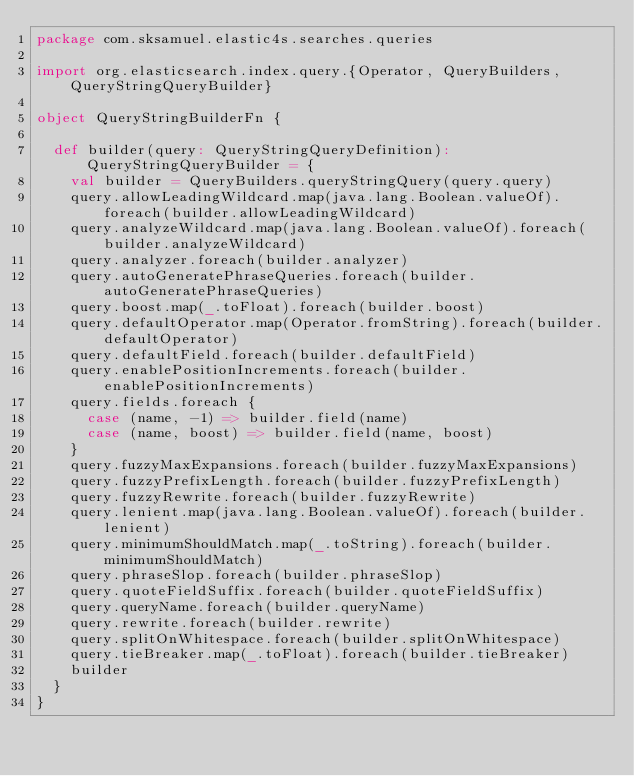Convert code to text. <code><loc_0><loc_0><loc_500><loc_500><_Scala_>package com.sksamuel.elastic4s.searches.queries

import org.elasticsearch.index.query.{Operator, QueryBuilders, QueryStringQueryBuilder}

object QueryStringBuilderFn {

  def builder(query: QueryStringQueryDefinition): QueryStringQueryBuilder = {
    val builder = QueryBuilders.queryStringQuery(query.query)
    query.allowLeadingWildcard.map(java.lang.Boolean.valueOf).foreach(builder.allowLeadingWildcard)
    query.analyzeWildcard.map(java.lang.Boolean.valueOf).foreach(builder.analyzeWildcard)
    query.analyzer.foreach(builder.analyzer)
    query.autoGeneratePhraseQueries.foreach(builder.autoGeneratePhraseQueries)
    query.boost.map(_.toFloat).foreach(builder.boost)
    query.defaultOperator.map(Operator.fromString).foreach(builder.defaultOperator)
    query.defaultField.foreach(builder.defaultField)
    query.enablePositionIncrements.foreach(builder.enablePositionIncrements)
    query.fields.foreach {
      case (name, -1) => builder.field(name)
      case (name, boost) => builder.field(name, boost)
    }
    query.fuzzyMaxExpansions.foreach(builder.fuzzyMaxExpansions)
    query.fuzzyPrefixLength.foreach(builder.fuzzyPrefixLength)
    query.fuzzyRewrite.foreach(builder.fuzzyRewrite)
    query.lenient.map(java.lang.Boolean.valueOf).foreach(builder.lenient)
    query.minimumShouldMatch.map(_.toString).foreach(builder.minimumShouldMatch)
    query.phraseSlop.foreach(builder.phraseSlop)
    query.quoteFieldSuffix.foreach(builder.quoteFieldSuffix)
    query.queryName.foreach(builder.queryName)
    query.rewrite.foreach(builder.rewrite)
    query.splitOnWhitespace.foreach(builder.splitOnWhitespace)
    query.tieBreaker.map(_.toFloat).foreach(builder.tieBreaker)
    builder
  }
}
</code> 